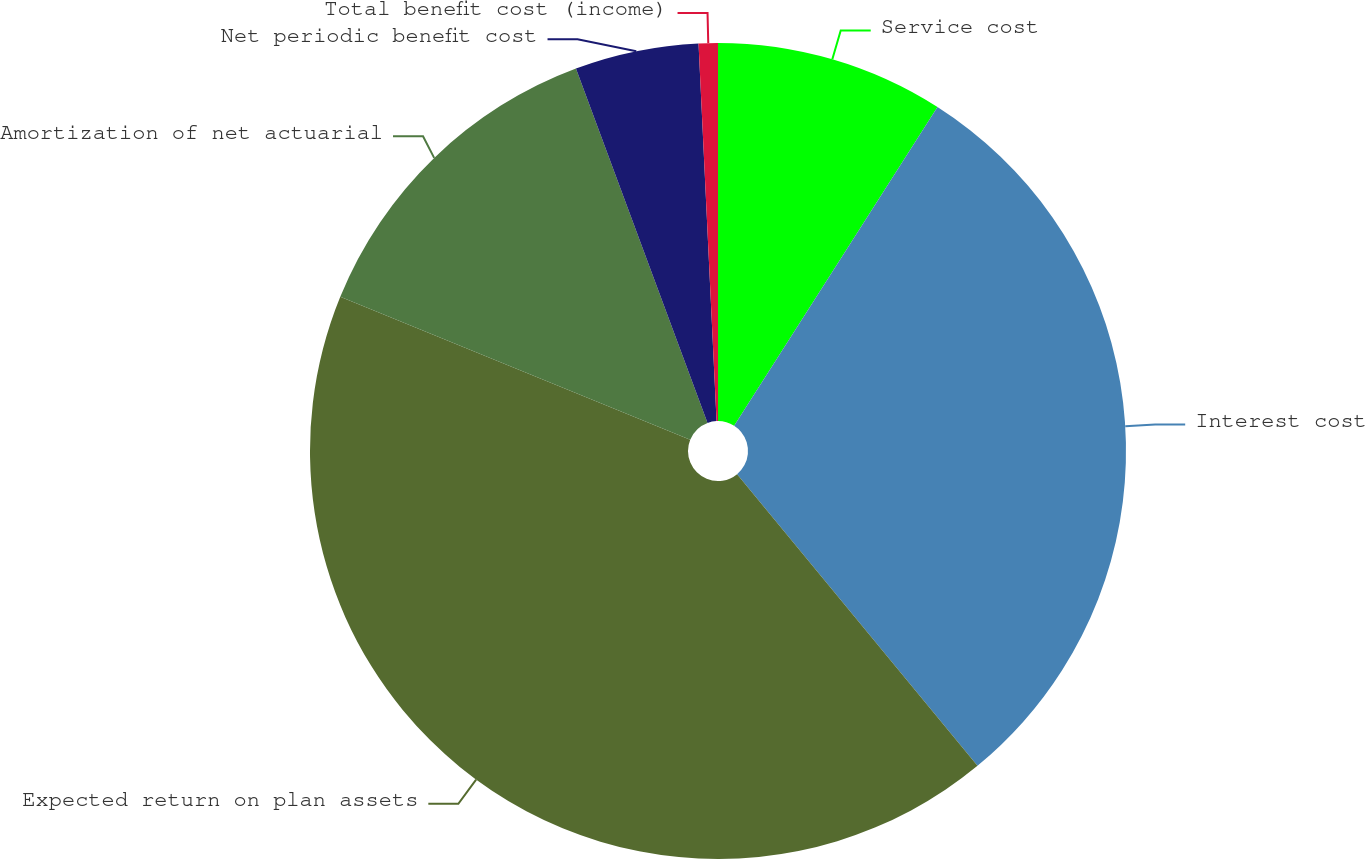Convert chart. <chart><loc_0><loc_0><loc_500><loc_500><pie_chart><fcel>Service cost<fcel>Interest cost<fcel>Expected return on plan assets<fcel>Amortization of net actuarial<fcel>Net periodic benefit cost<fcel>Total benefit cost (income)<nl><fcel>9.04%<fcel>29.99%<fcel>42.14%<fcel>13.17%<fcel>4.9%<fcel>0.76%<nl></chart> 